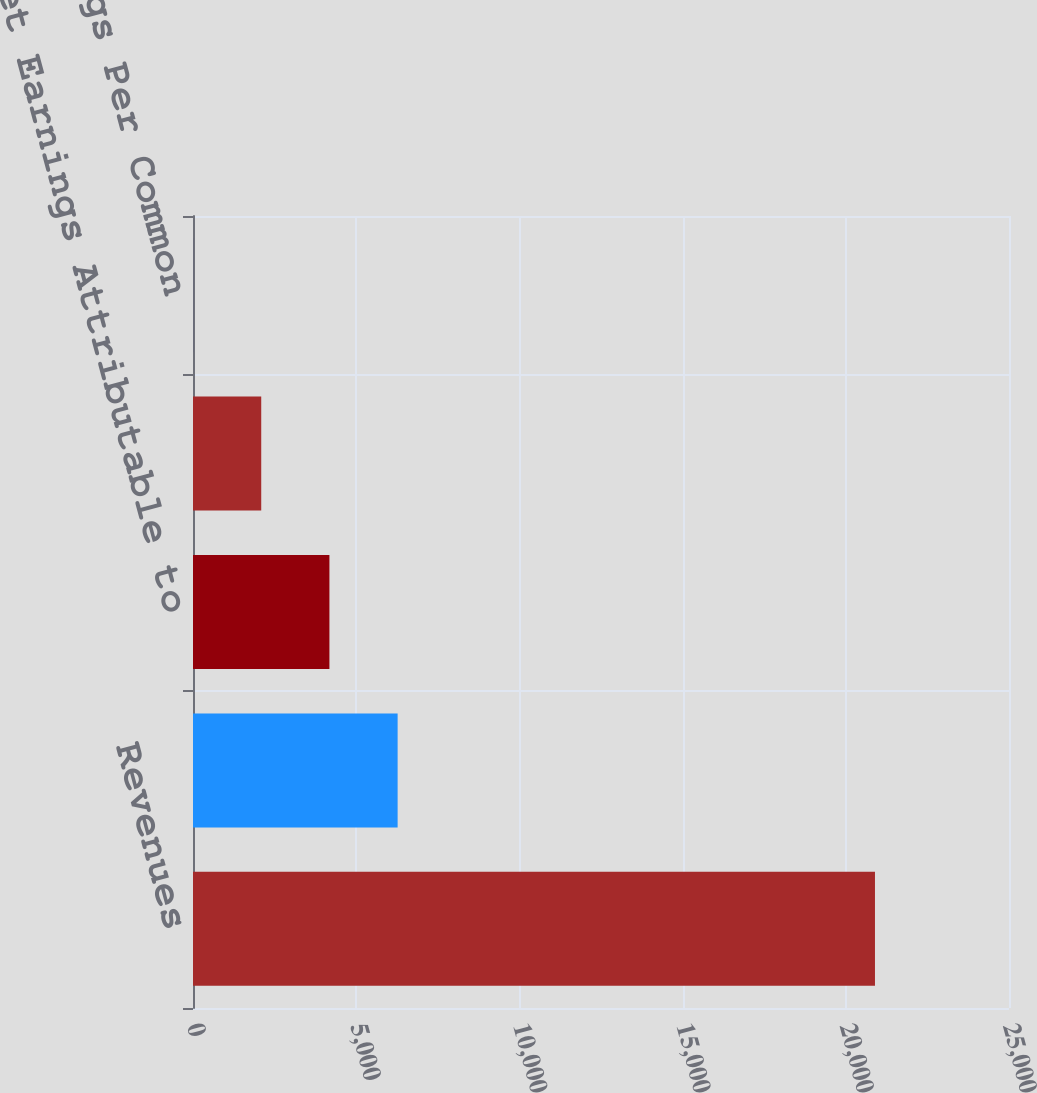Convert chart to OTSL. <chart><loc_0><loc_0><loc_500><loc_500><bar_chart><fcel>Revenues<fcel>Gross Profit<fcel>Net Earnings Attributable to<fcel>Basic Earnings Per Common<fcel>Diluted Earnings Per Common<nl><fcel>20894<fcel>6268.95<fcel>4179.66<fcel>2090.37<fcel>1.08<nl></chart> 